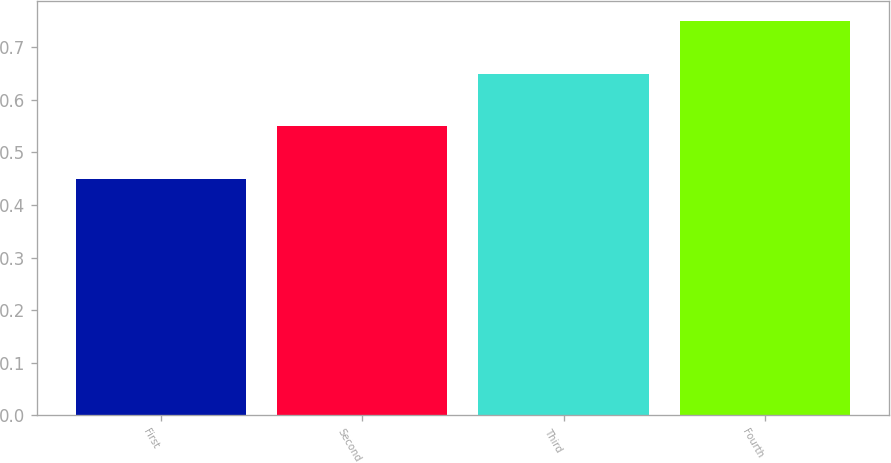Convert chart. <chart><loc_0><loc_0><loc_500><loc_500><bar_chart><fcel>First<fcel>Second<fcel>Third<fcel>Fourth<nl><fcel>0.45<fcel>0.55<fcel>0.65<fcel>0.75<nl></chart> 